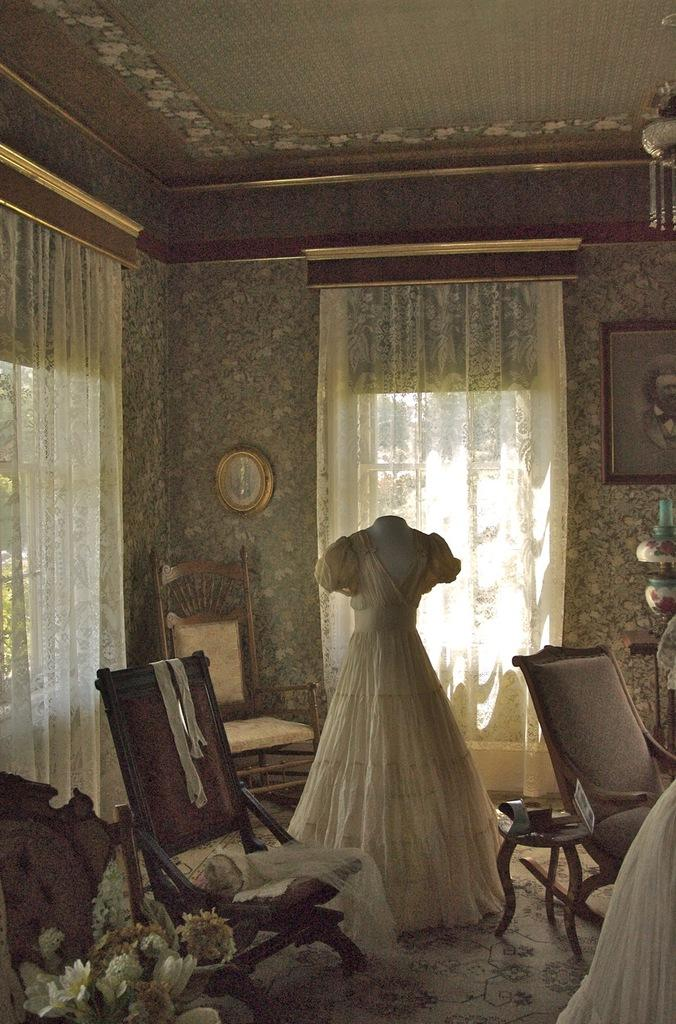What type of clothing is featured in the image? There is a gown in the image. How many chairs are visible in the image? There are three chairs in the image. What type of decorative elements can be seen in the image? There are flowers, a lamp, and a frame in the image. How many curtains are present in the image? There are two curtains in the image. What time-keeping device is on the wall in the image? There is a clock on the wall in the image. What type of muscle is being flexed by the person wearing the gown in the image? There is no person wearing the gown in the image, and therefore no muscle flexing can be observed. What is the brain doing in the image? There is no brain present in the image. 